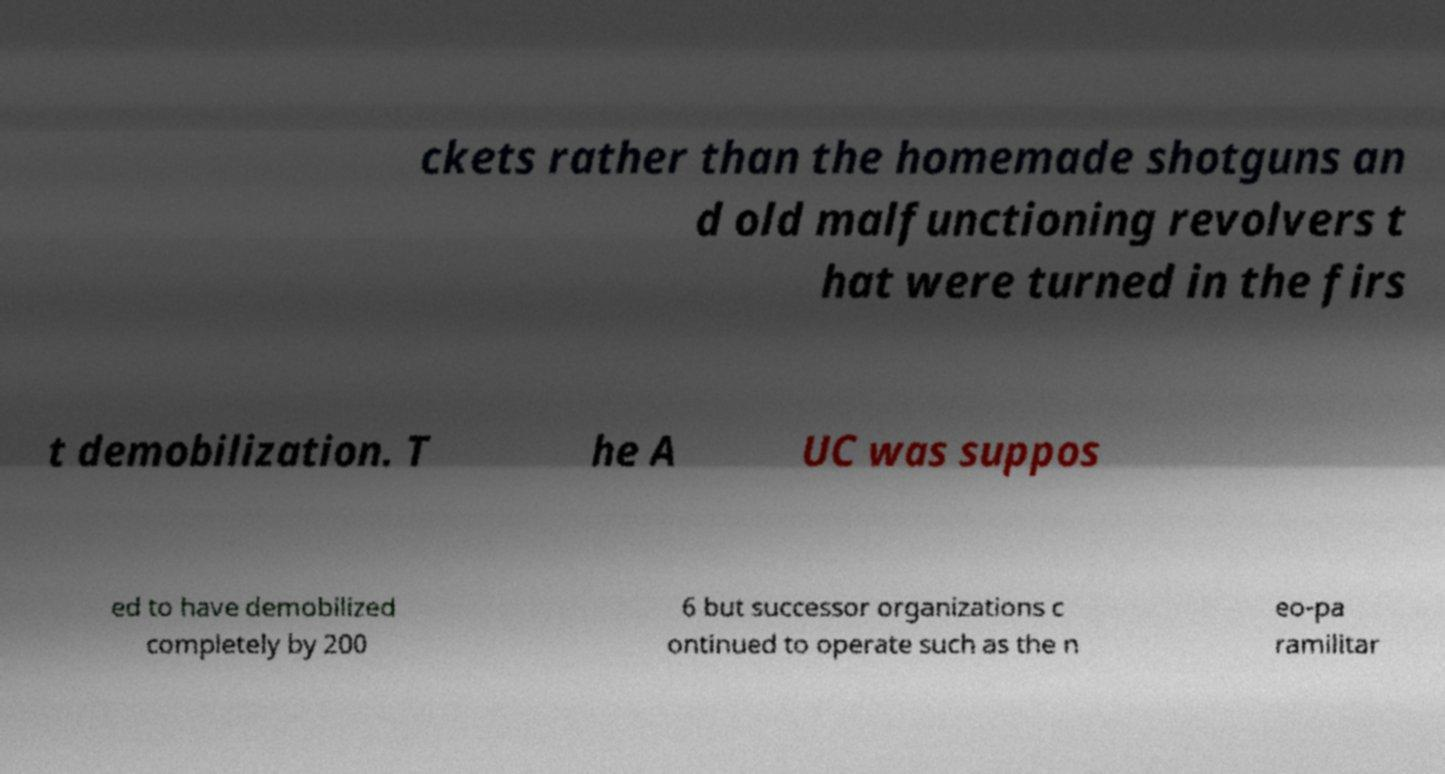Please identify and transcribe the text found in this image. ckets rather than the homemade shotguns an d old malfunctioning revolvers t hat were turned in the firs t demobilization. T he A UC was suppos ed to have demobilized completely by 200 6 but successor organizations c ontinued to operate such as the n eo-pa ramilitar 